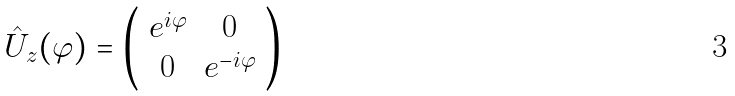Convert formula to latex. <formula><loc_0><loc_0><loc_500><loc_500>\hat { U } _ { z } ( \varphi ) = \left ( \begin{array} { c c } e ^ { i \varphi } & 0 \\ 0 & e ^ { - i \varphi } \end{array} \right )</formula> 